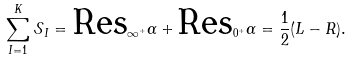<formula> <loc_0><loc_0><loc_500><loc_500>\sum _ { I = 1 } ^ { K } \mathcal { S } _ { I } = \text {Res} _ { \infty ^ { + } } \alpha + \text {Res} _ { 0 ^ { + } } \alpha = \frac { 1 } { 2 } ( L - R ) .</formula> 